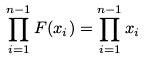Convert formula to latex. <formula><loc_0><loc_0><loc_500><loc_500>\prod _ { i = 1 } ^ { n - 1 } F ( x _ { i } ) = \prod _ { i = 1 } ^ { n - 1 } x _ { i }</formula> 